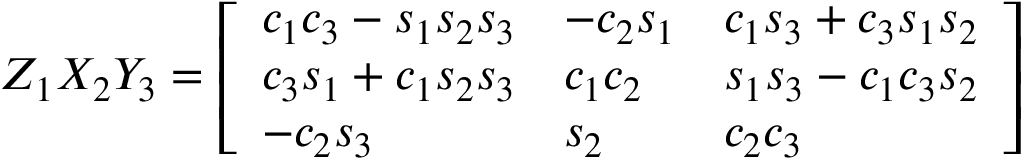<formula> <loc_0><loc_0><loc_500><loc_500>Z _ { 1 } X _ { 2 } Y _ { 3 } = { \left [ \begin{array} { l l l } { c _ { 1 } c _ { 3 } - s _ { 1 } s _ { 2 } s _ { 3 } } & { - c _ { 2 } s _ { 1 } } & { c _ { 1 } s _ { 3 } + c _ { 3 } s _ { 1 } s _ { 2 } } \\ { c _ { 3 } s _ { 1 } + c _ { 1 } s _ { 2 } s _ { 3 } } & { c _ { 1 } c _ { 2 } } & { s _ { 1 } s _ { 3 } - c _ { 1 } c _ { 3 } s _ { 2 } } \\ { - c _ { 2 } s _ { 3 } } & { s _ { 2 } } & { c _ { 2 } c _ { 3 } } \end{array} \right ] }</formula> 